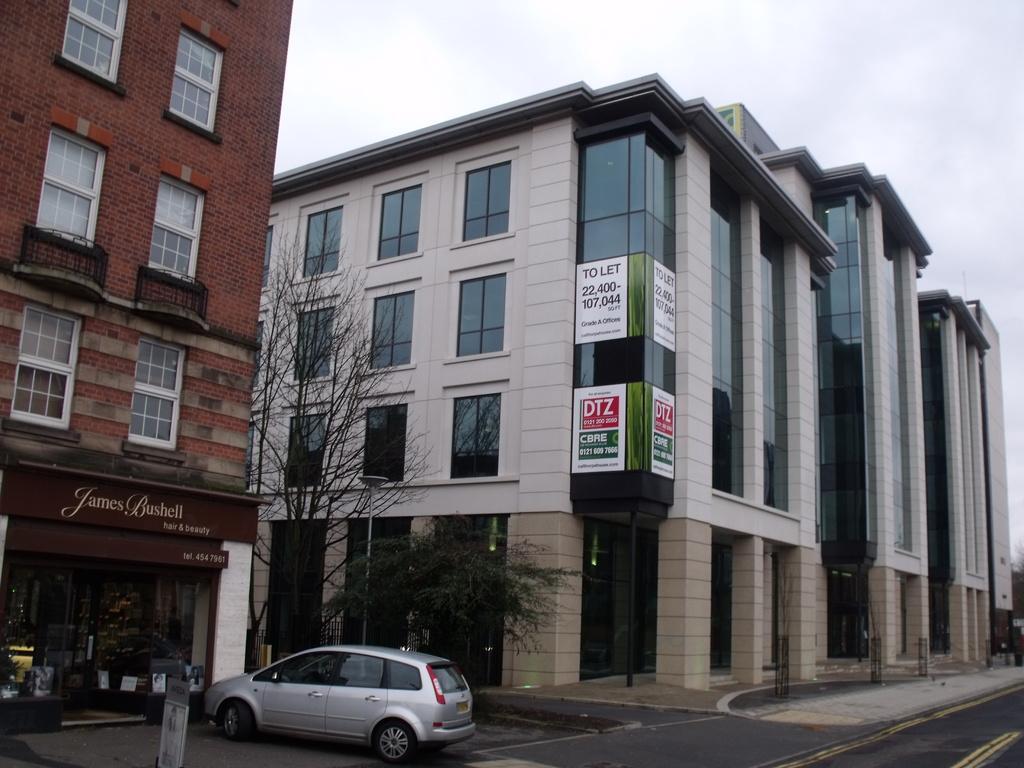Please provide a concise description of this image. In the center of the picture there are buildings and trees. In the foreground there are cars and footpath and road. Sky is cloudy. 